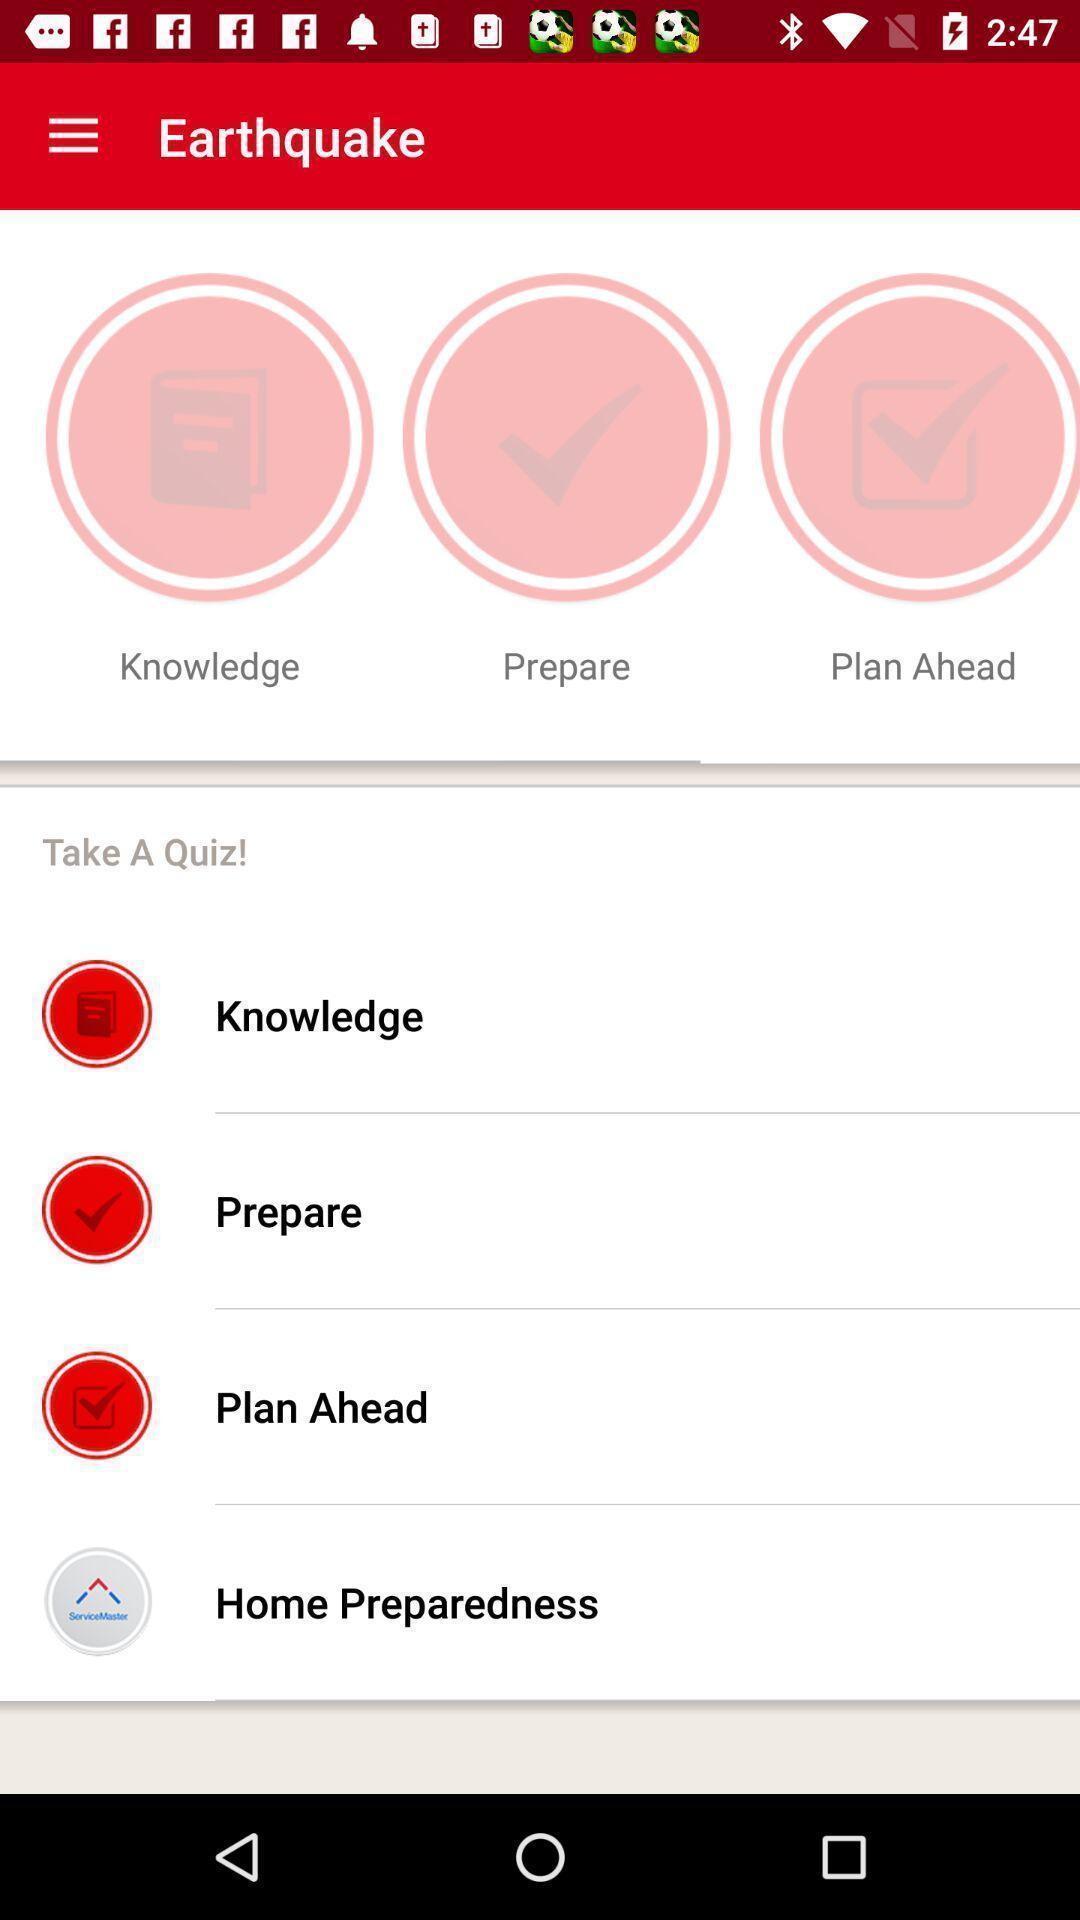Explain the elements present in this screenshot. Page displays to take a quiz in learning app. 